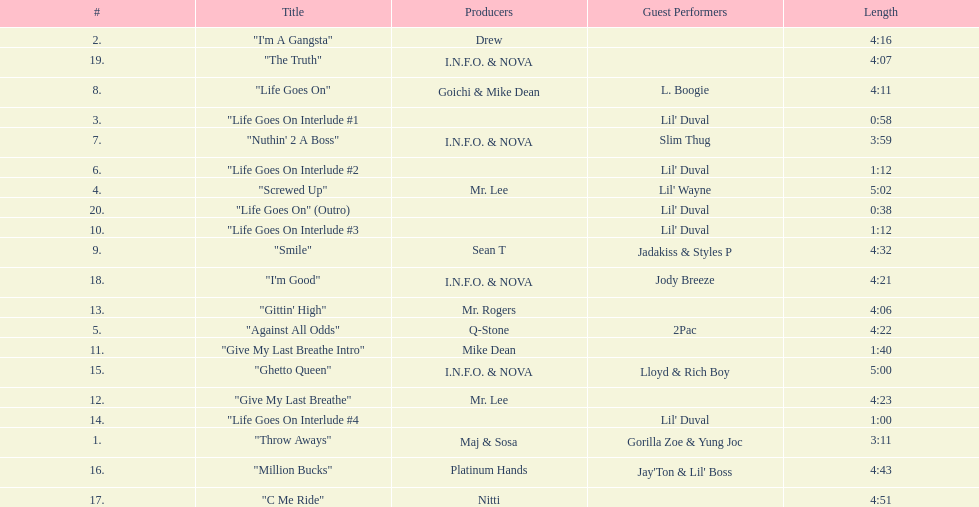What is the first track featuring lil' duval? "Life Goes On Interlude #1. 